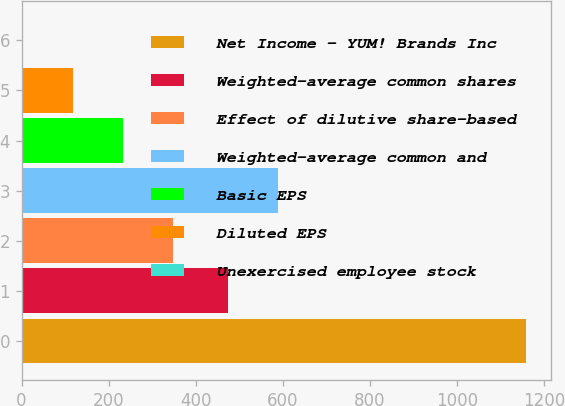<chart> <loc_0><loc_0><loc_500><loc_500><bar_chart><fcel>Net Income - YUM! Brands Inc<fcel>Weighted-average common shares<fcel>Effect of dilutive share-based<fcel>Weighted-average common and<fcel>Basic EPS<fcel>Diluted EPS<fcel>Unexercised employee stock<nl><fcel>1158<fcel>474<fcel>348.94<fcel>589.58<fcel>233.36<fcel>117.78<fcel>2.2<nl></chart> 